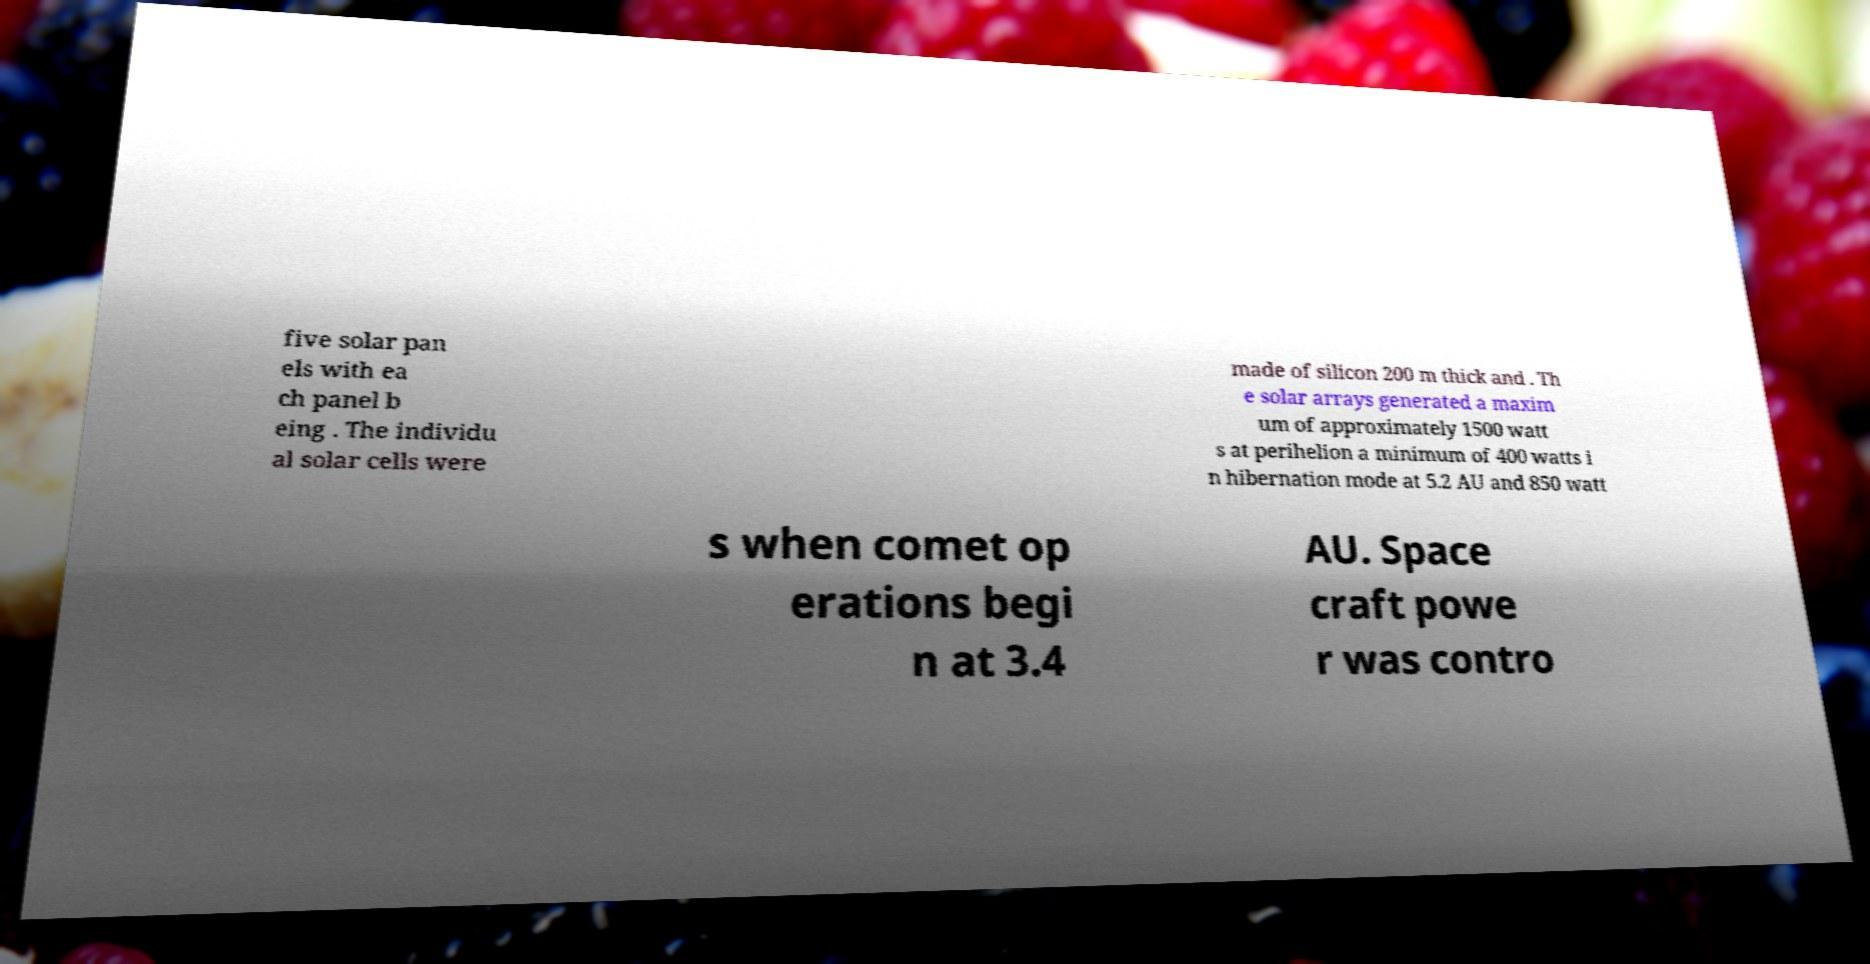Please identify and transcribe the text found in this image. five solar pan els with ea ch panel b eing . The individu al solar cells were made of silicon 200 m thick and . Th e solar arrays generated a maxim um of approximately 1500 watt s at perihelion a minimum of 400 watts i n hibernation mode at 5.2 AU and 850 watt s when comet op erations begi n at 3.4 AU. Space craft powe r was contro 